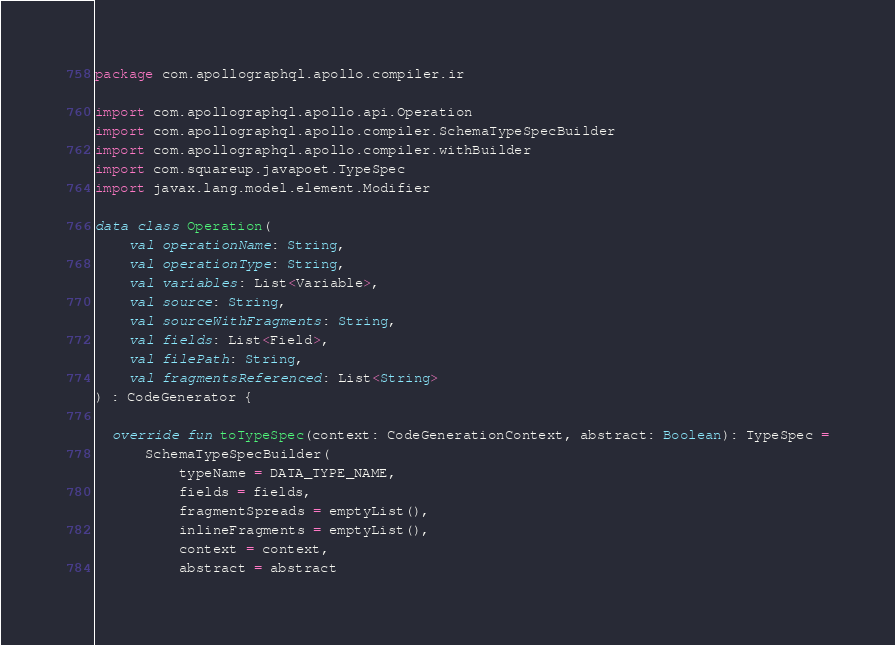<code> <loc_0><loc_0><loc_500><loc_500><_Kotlin_>package com.apollographql.apollo.compiler.ir

import com.apollographql.apollo.api.Operation
import com.apollographql.apollo.compiler.SchemaTypeSpecBuilder
import com.apollographql.apollo.compiler.withBuilder
import com.squareup.javapoet.TypeSpec
import javax.lang.model.element.Modifier

data class Operation(
    val operationName: String,
    val operationType: String,
    val variables: List<Variable>,
    val source: String,
    val sourceWithFragments: String,
    val fields: List<Field>,
    val filePath: String,
    val fragmentsReferenced: List<String>
) : CodeGenerator {

  override fun toTypeSpec(context: CodeGenerationContext, abstract: Boolean): TypeSpec =
      SchemaTypeSpecBuilder(
          typeName = DATA_TYPE_NAME,
          fields = fields,
          fragmentSpreads = emptyList(),
          inlineFragments = emptyList(),
          context = context,
          abstract = abstract</code> 